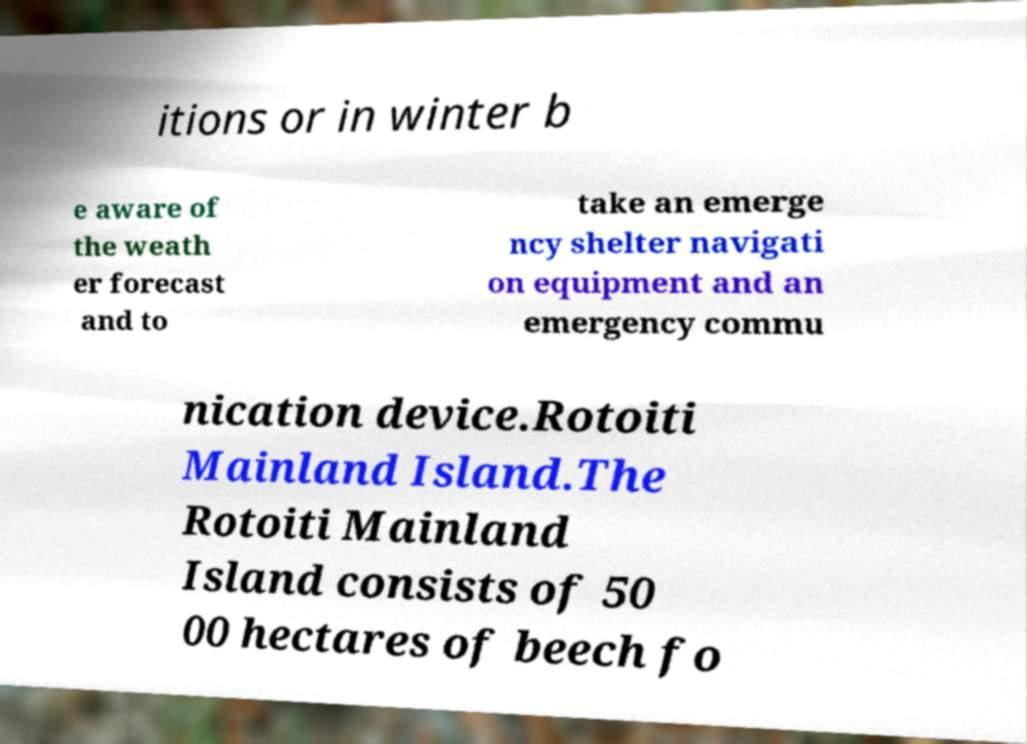There's text embedded in this image that I need extracted. Can you transcribe it verbatim? itions or in winter b e aware of the weath er forecast and to take an emerge ncy shelter navigati on equipment and an emergency commu nication device.Rotoiti Mainland Island.The Rotoiti Mainland Island consists of 50 00 hectares of beech fo 